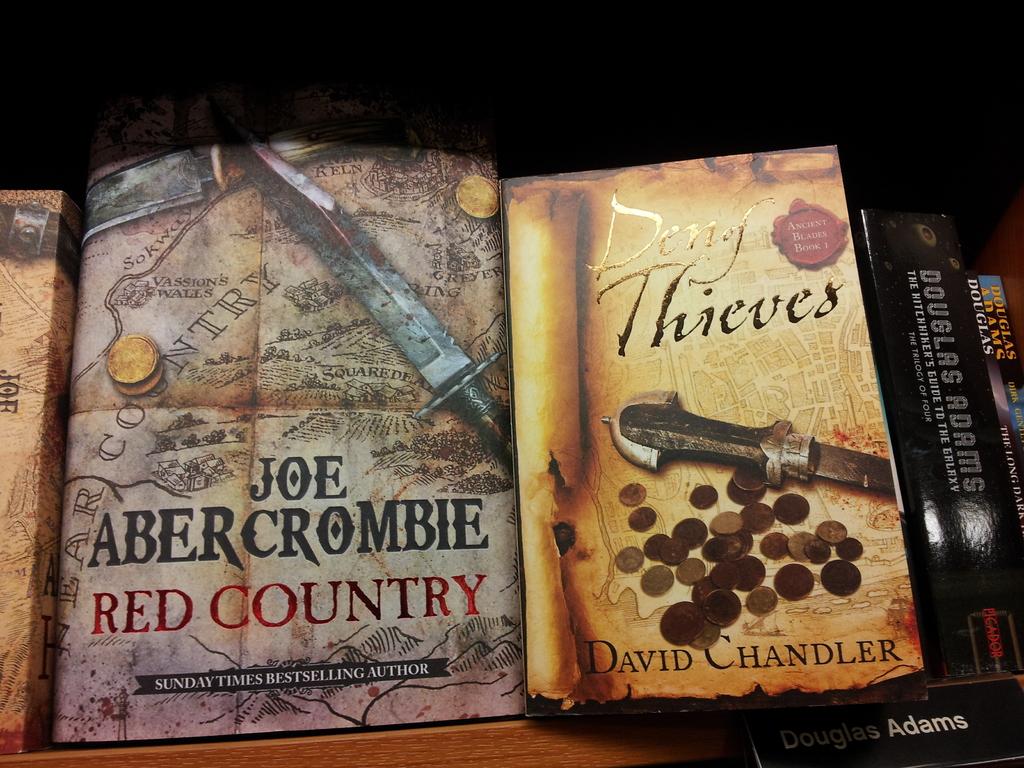What is the name of joe abercrombie's novel?
Make the answer very short. Red country. What's the name of the book on the right?
Give a very brief answer. Den of thieves. 